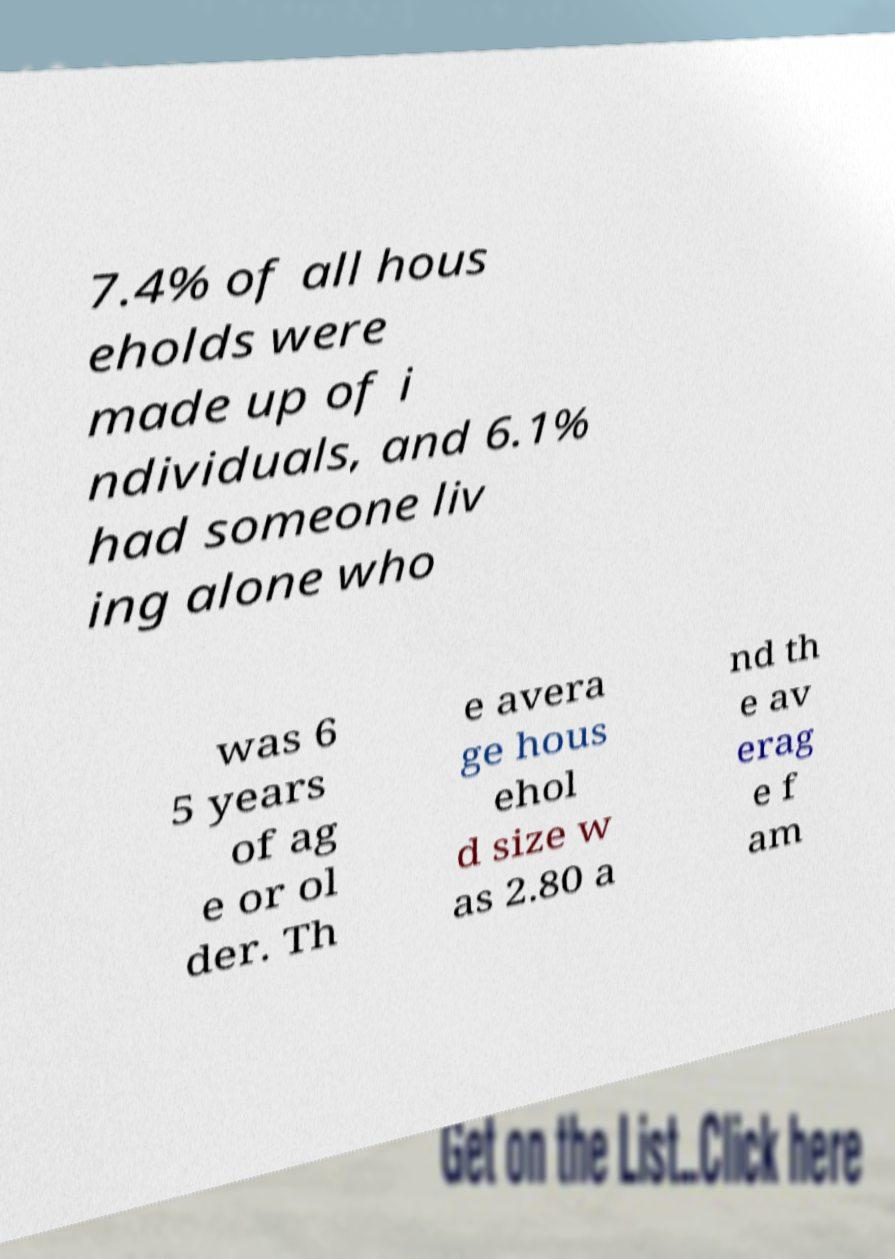Could you assist in decoding the text presented in this image and type it out clearly? 7.4% of all hous eholds were made up of i ndividuals, and 6.1% had someone liv ing alone who was 6 5 years of ag e or ol der. Th e avera ge hous ehol d size w as 2.80 a nd th e av erag e f am 